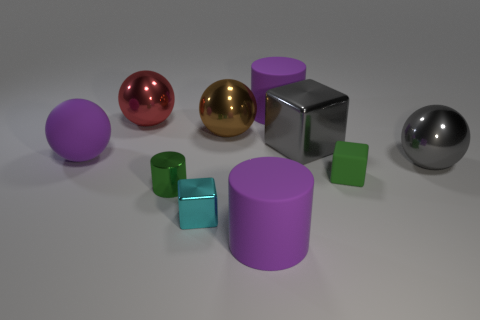Subtract all blocks. How many objects are left? 7 Subtract 0 brown cylinders. How many objects are left? 10 Subtract all cyan shiny cylinders. Subtract all large shiny blocks. How many objects are left? 9 Add 3 rubber cubes. How many rubber cubes are left? 4 Add 8 tiny gray metal spheres. How many tiny gray metal spheres exist? 8 